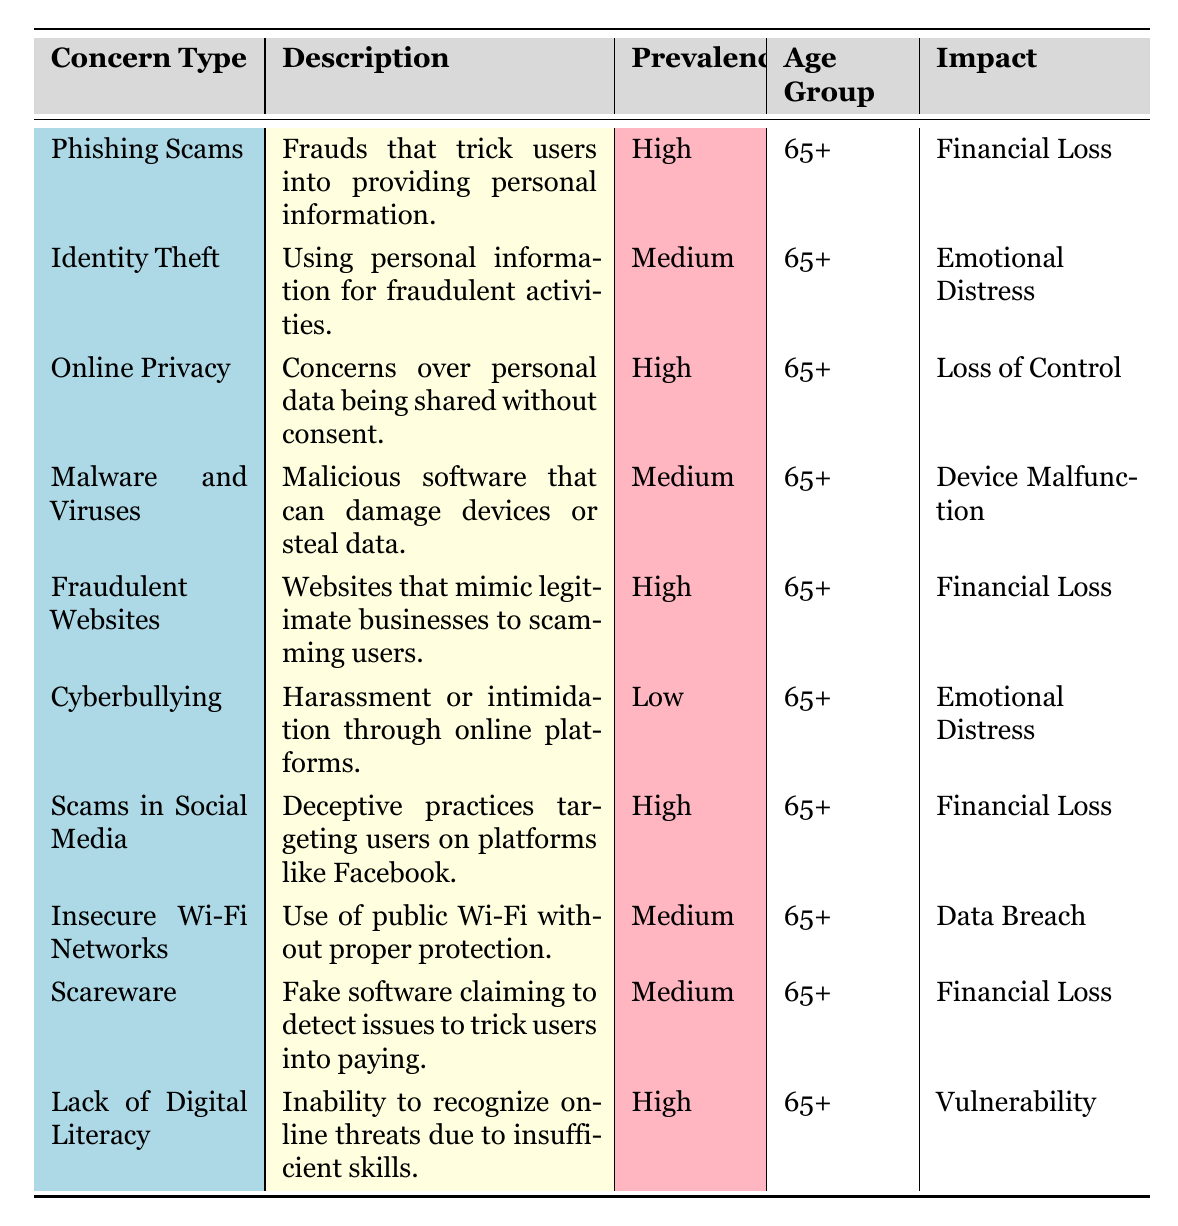What is the prevalence of Phishing Scams? The table lists Phishing Scams under the 'Prevalence' column and indicates that it is "High."
Answer: High How many types of concerns are listed in the table? The table has 10 rows, each representing a unique 'Concern Type,' so there are 10 types of concerns listed.
Answer: 10 Is Online Privacy a concern for the "65+" age group? Yes, the table shows that Online Privacy is listed under the 'Age Group' column as "65+."
Answer: Yes Which concern has the lowest prevalence? Looking through the 'Prevalence' column, only Cyberbullying is marked as "Low," making it the concern with the lowest prevalence.
Answer: Cyberbullying What is the total number of concerns that have a "High" prevalence? There are five concerns marked as "High" in the 'Prevalence' column: Phishing Scams, Online Privacy, Fraudulent Websites, Scams in Social Media, and Lack of Digital Literacy. Therefore, the total is 5.
Answer: 5 What is the primary impact of Fraudulent Websites? The table lists Fraudulent Websites under 'Impact' as causing "Financial Loss."
Answer: Financial Loss Is there any concern that has a "Medium" prevalence and causes "Device Malfunction"? Yes, Malware and Viruses has a "Medium" prevalence and lists "Device Malfunction" as its impact.
Answer: Yes Which two concerns have "Emotional Distress" listed as their impact? The table shows Identity Theft and Cyberbullying both have "Emotional Distress" listed under the 'Impact' column.
Answer: Identity Theft and Cyberbullying If we consider only the concerns that are categorized as "High," what impact do they have? The impacts of the "High" concerns (labeled in the table) are: Financial Loss (3), Loss of Control (1), and Vulnerability (1). Therefore, the impact is predominantly Financial Loss.
Answer: Financial Loss 